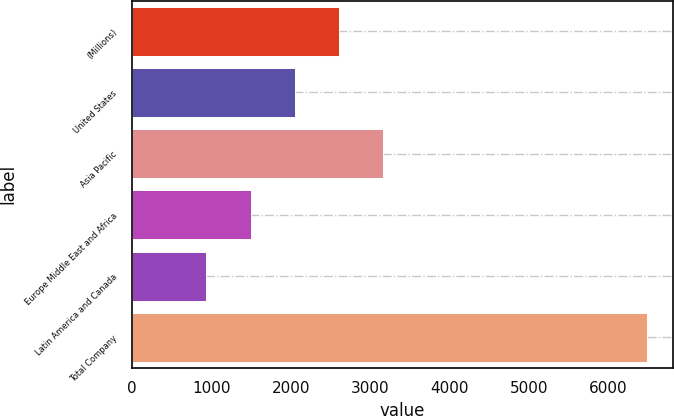Convert chart to OTSL. <chart><loc_0><loc_0><loc_500><loc_500><bar_chart><fcel>(Millions)<fcel>United States<fcel>Asia Pacific<fcel>Europe Middle East and Africa<fcel>Latin America and Canada<fcel>Total Company<nl><fcel>2600.1<fcel>2045.4<fcel>3154.8<fcel>1490.7<fcel>936<fcel>6483<nl></chart> 